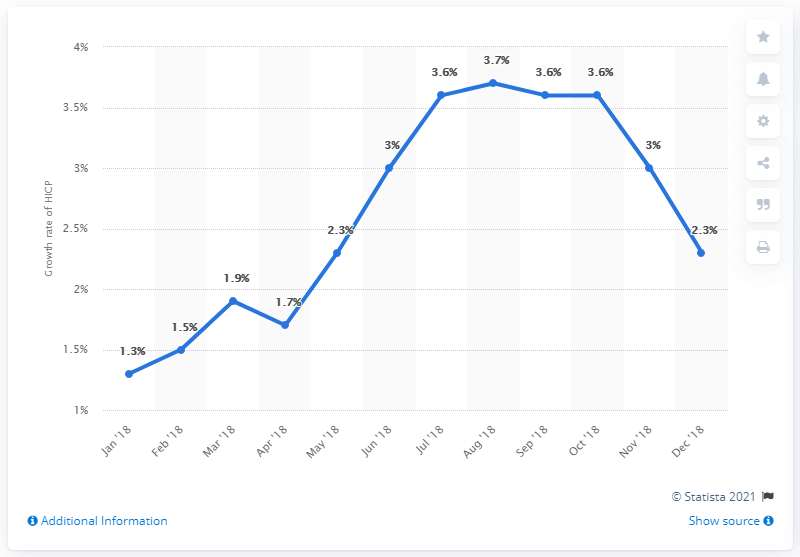Indicate a few pertinent items in this graphic. In December 2018, the inflation rate was 2.3%. 